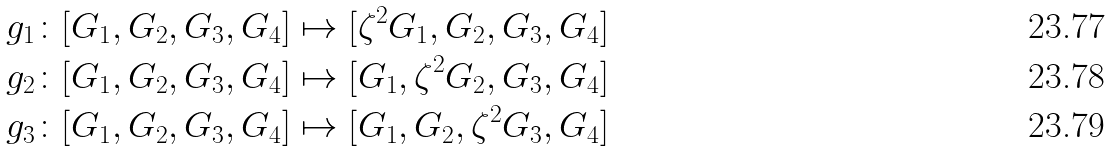<formula> <loc_0><loc_0><loc_500><loc_500>g _ { 1 } \colon [ G _ { 1 } , G _ { 2 } , G _ { 3 } , G _ { 4 } ] & \mapsto [ \zeta ^ { 2 } G _ { 1 } , G _ { 2 } , G _ { 3 } , G _ { 4 } ] \\ g _ { 2 } \colon [ G _ { 1 } , G _ { 2 } , G _ { 3 } , G _ { 4 } ] & \mapsto [ G _ { 1 } , \zeta ^ { 2 } G _ { 2 } , G _ { 3 } , G _ { 4 } ] \\ g _ { 3 } \colon [ G _ { 1 } , G _ { 2 } , G _ { 3 } , G _ { 4 } ] & \mapsto [ G _ { 1 } , G _ { 2 } , \zeta ^ { 2 } G _ { 3 } , G _ { 4 } ]</formula> 